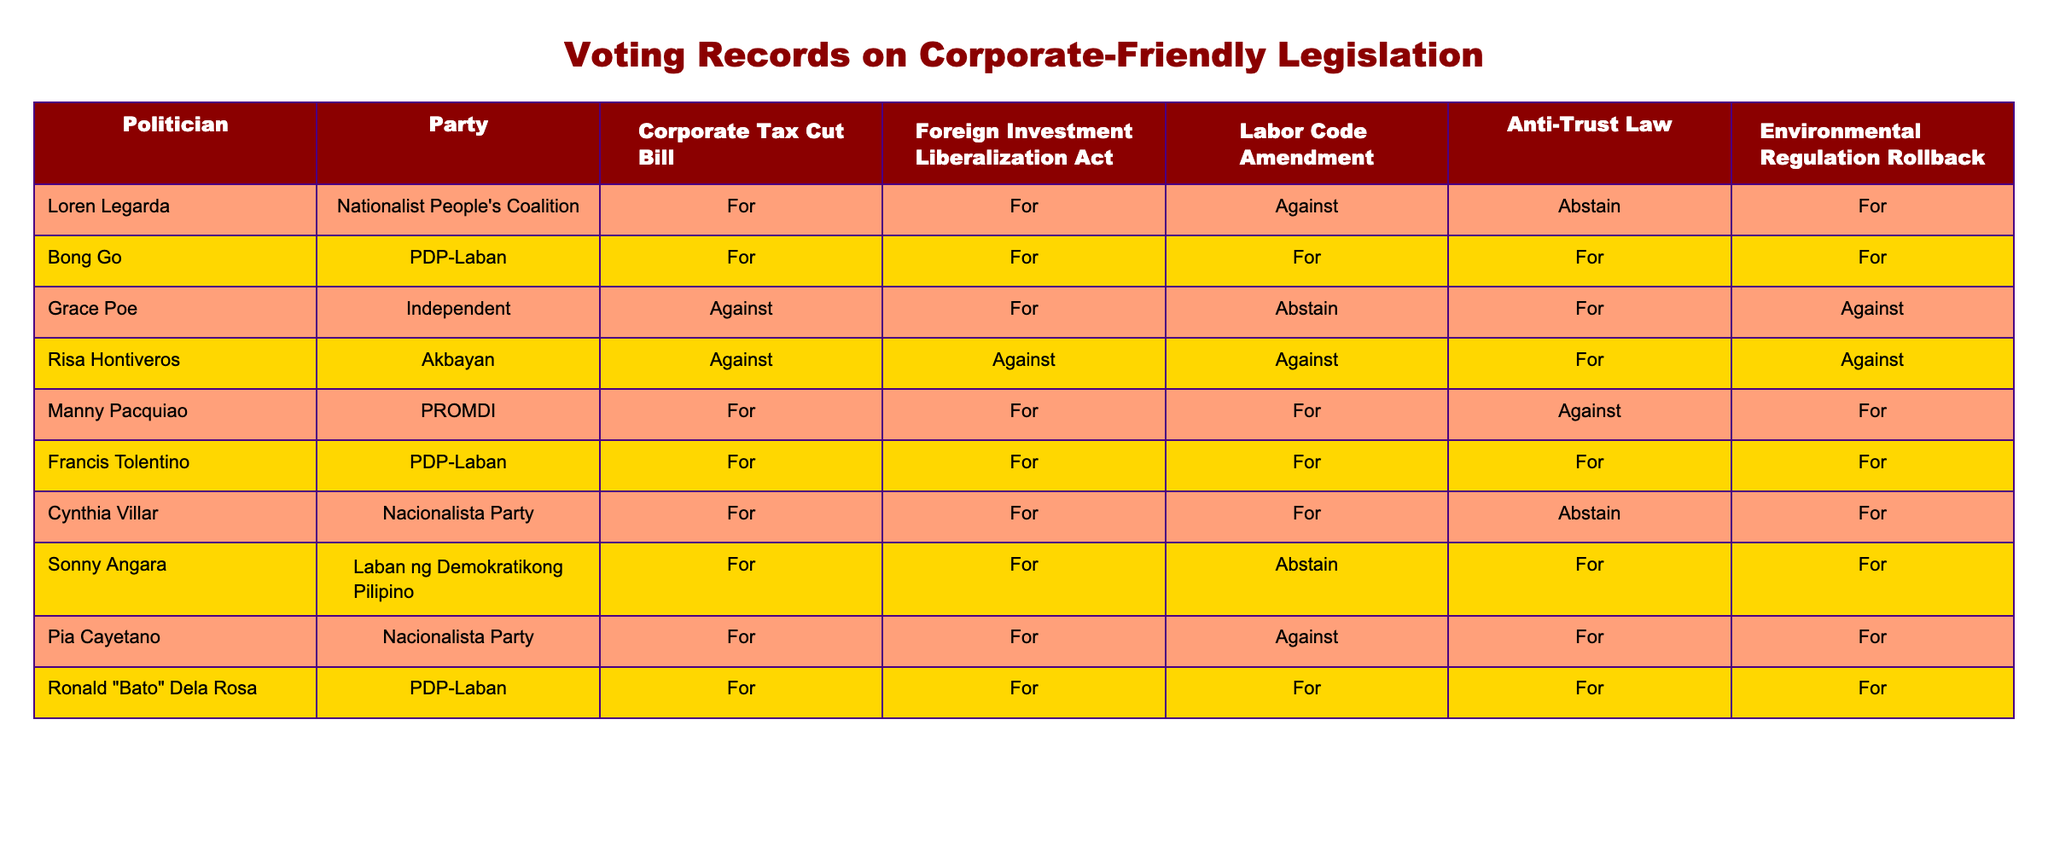What is the voting stance of Risa Hontiveros on the Corporate Tax Cut Bill? According to the table, Risa Hontiveros voted "Against" the Corporate Tax Cut Bill. This can be directly observed in her row under the column for the Corporate Tax Cut Bill.
Answer: Against How many politicians voted "For" the Labor Code Amendment? By examining the table, we see that the politicians who voted "For" the Labor Code Amendment are Bong Go, Manny Pacquiao, and Sonny Angara. Counting these politicians gives us a total of 3 votes in favor.
Answer: 3 Did any politician abstain from voting on the Environmental Regulation Rollback? The table shows that Loren Legarda and Cynthia Villar both abstained from voting on the Environmental Regulation Rollback. We confirm their abstention by locating their votes in the respective column.
Answer: Yes Which politician had the most corporate-friendly votes? To determine this, we count how many votes each politician has "For." Bong Go, Francis Tolentino, and Ronald "Bato" Dela Rosa each voted "For" all five categories. Thus, they share the highest count of 5 corporate-friendly votes.
Answer: Bong Go, Francis Tolentino, Ronald "Bato" Dela Rosa What is the difference in the number of "For" votes between Loren Legarda and Risa Hontiveros? Loren Legarda has 4 "For" votes (Corporate Tax Cut Bill, Foreign Investment Liberalization Act, Environmental Regulation Rollback, and one abstain), while Risa Hontiveros has 1 "For" vote (Anti-Trust Law). Calculating the difference gives us 4 - 1 = 3.
Answer: 3 